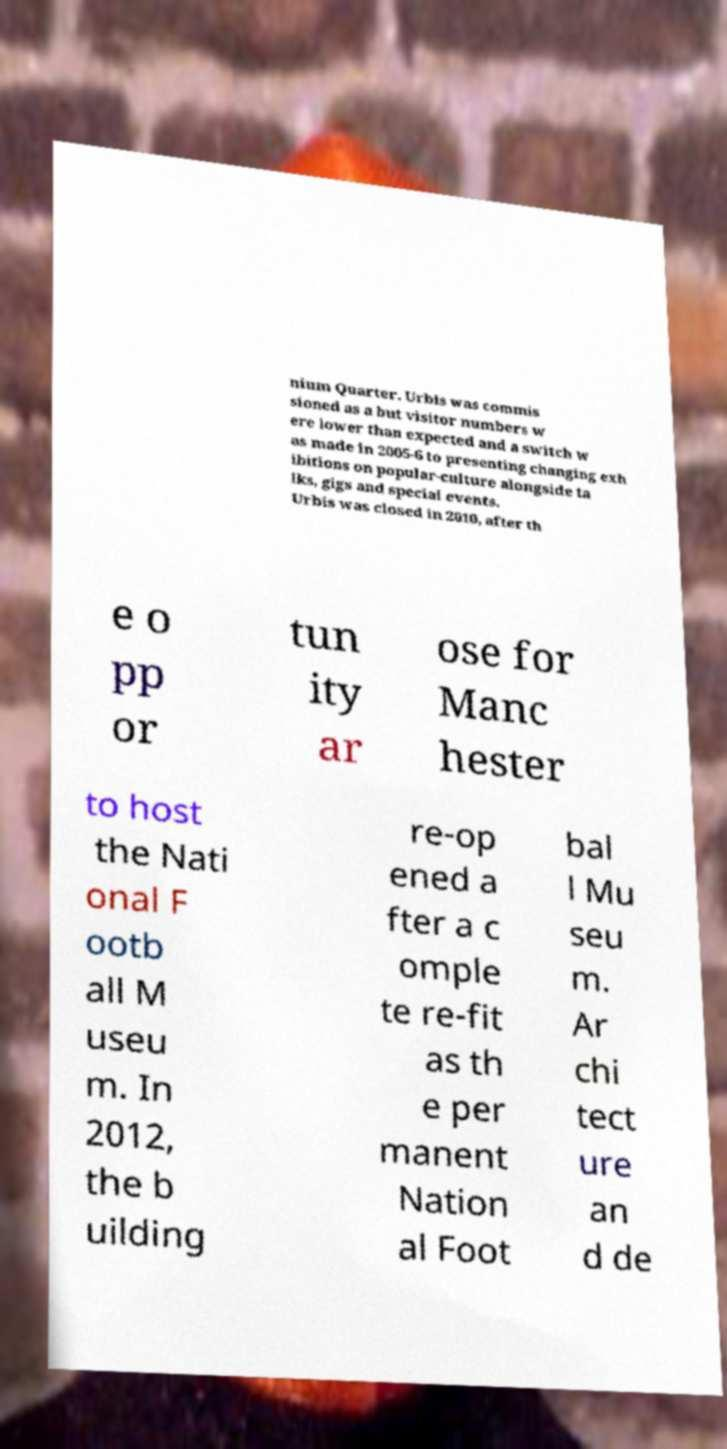Please identify and transcribe the text found in this image. nium Quarter. Urbis was commis sioned as a but visitor numbers w ere lower than expected and a switch w as made in 2005-6 to presenting changing exh ibitions on popular-culture alongside ta lks, gigs and special events. Urbis was closed in 2010, after th e o pp or tun ity ar ose for Manc hester to host the Nati onal F ootb all M useu m. In 2012, the b uilding re-op ened a fter a c omple te re-fit as th e per manent Nation al Foot bal l Mu seu m. Ar chi tect ure an d de 